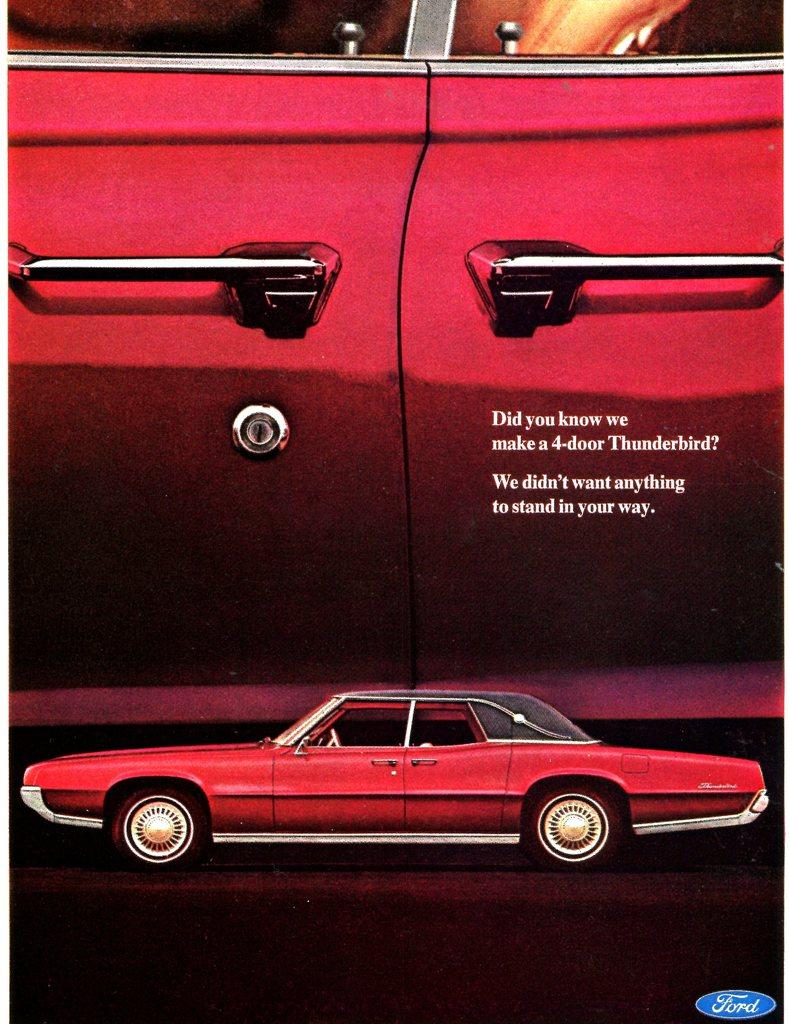What is featured in the image? There is a poster in the image. What is depicted on the poster? The poster is of a car. What color is the car on the poster? The car on the poster is red in color. Can you see any grains of sand on the island in the image? There is no island or sand present in the image; it features a poster of a red car. 